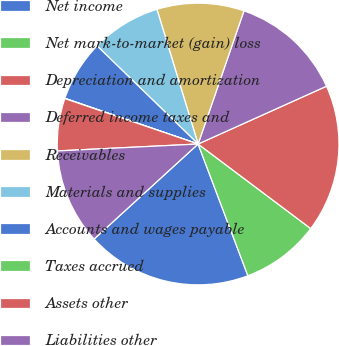Convert chart to OTSL. <chart><loc_0><loc_0><loc_500><loc_500><pie_chart><fcel>Net income<fcel>Net mark-to-market (gain) loss<fcel>Depreciation and amortization<fcel>Deferred income taxes and<fcel>Receivables<fcel>Materials and supplies<fcel>Accounts and wages payable<fcel>Taxes accrued<fcel>Assets other<fcel>Liabilities other<nl><fcel>18.97%<fcel>9.0%<fcel>16.98%<fcel>12.99%<fcel>10.0%<fcel>8.01%<fcel>7.01%<fcel>0.03%<fcel>6.01%<fcel>11.0%<nl></chart> 